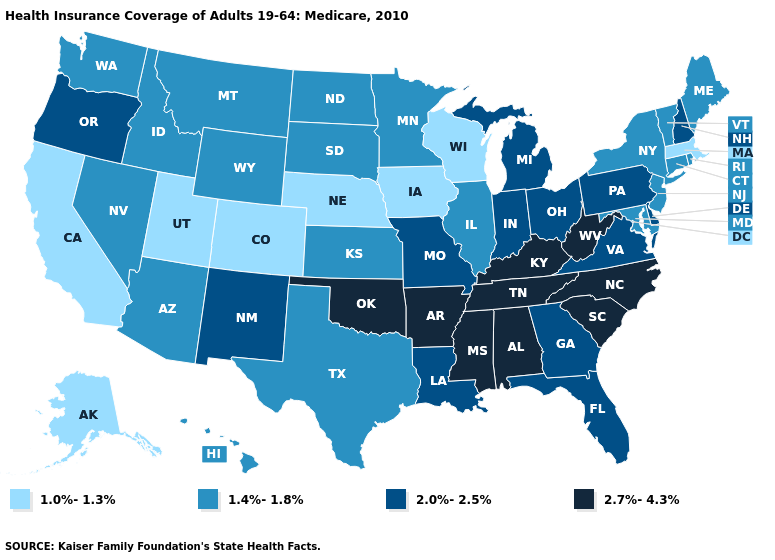How many symbols are there in the legend?
Give a very brief answer. 4. Name the states that have a value in the range 2.0%-2.5%?
Write a very short answer. Delaware, Florida, Georgia, Indiana, Louisiana, Michigan, Missouri, New Hampshire, New Mexico, Ohio, Oregon, Pennsylvania, Virginia. What is the value of Louisiana?
Write a very short answer. 2.0%-2.5%. What is the lowest value in states that border Oklahoma?
Quick response, please. 1.0%-1.3%. Among the states that border Utah , does Idaho have the lowest value?
Short answer required. No. Name the states that have a value in the range 2.0%-2.5%?
Quick response, please. Delaware, Florida, Georgia, Indiana, Louisiana, Michigan, Missouri, New Hampshire, New Mexico, Ohio, Oregon, Pennsylvania, Virginia. Which states hav the highest value in the MidWest?
Be succinct. Indiana, Michigan, Missouri, Ohio. What is the value of Maryland?
Short answer required. 1.4%-1.8%. Does Mississippi have the highest value in the USA?
Answer briefly. Yes. Name the states that have a value in the range 1.0%-1.3%?
Write a very short answer. Alaska, California, Colorado, Iowa, Massachusetts, Nebraska, Utah, Wisconsin. Name the states that have a value in the range 1.4%-1.8%?
Be succinct. Arizona, Connecticut, Hawaii, Idaho, Illinois, Kansas, Maine, Maryland, Minnesota, Montana, Nevada, New Jersey, New York, North Dakota, Rhode Island, South Dakota, Texas, Vermont, Washington, Wyoming. Among the states that border Ohio , does Michigan have the lowest value?
Answer briefly. Yes. Which states have the lowest value in the USA?
Concise answer only. Alaska, California, Colorado, Iowa, Massachusetts, Nebraska, Utah, Wisconsin. What is the value of Tennessee?
Be succinct. 2.7%-4.3%. What is the highest value in states that border North Carolina?
Quick response, please. 2.7%-4.3%. 